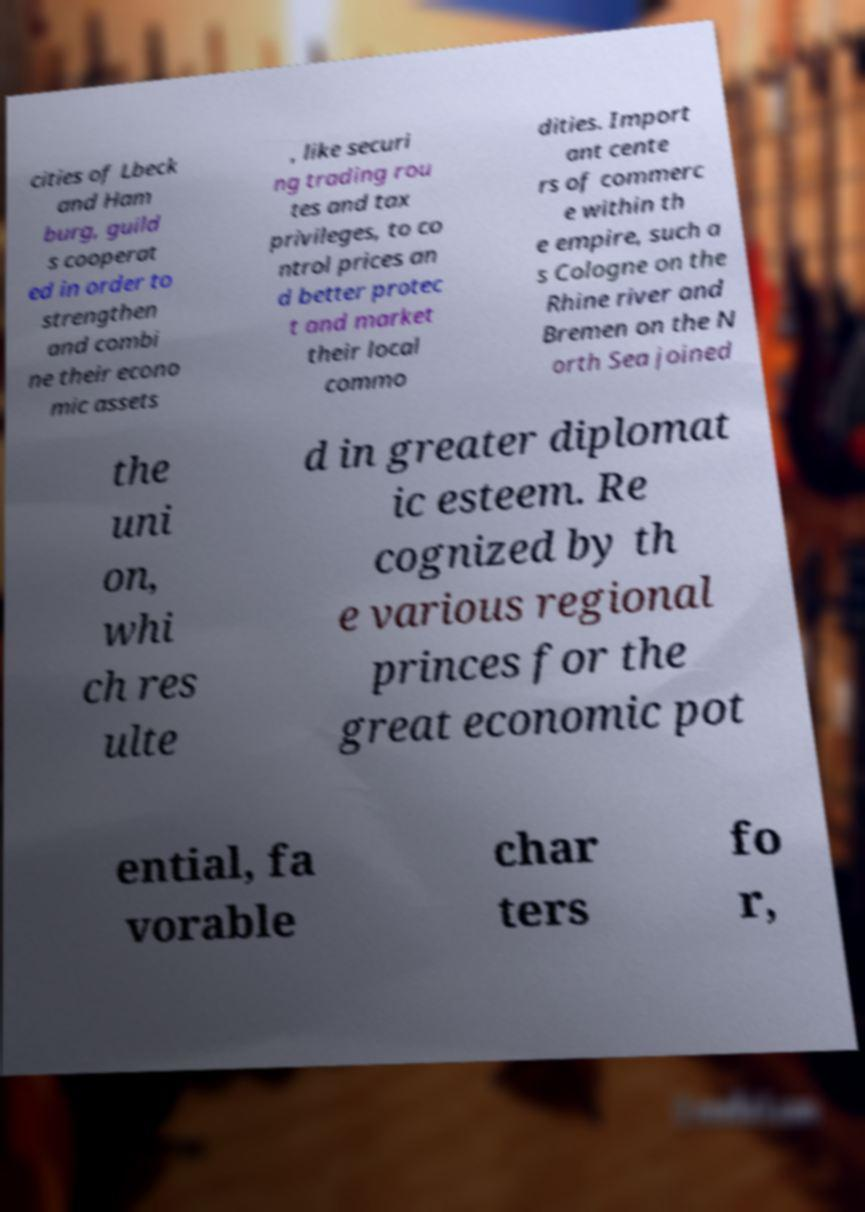Please identify and transcribe the text found in this image. cities of Lbeck and Ham burg, guild s cooperat ed in order to strengthen and combi ne their econo mic assets , like securi ng trading rou tes and tax privileges, to co ntrol prices an d better protec t and market their local commo dities. Import ant cente rs of commerc e within th e empire, such a s Cologne on the Rhine river and Bremen on the N orth Sea joined the uni on, whi ch res ulte d in greater diplomat ic esteem. Re cognized by th e various regional princes for the great economic pot ential, fa vorable char ters fo r, 